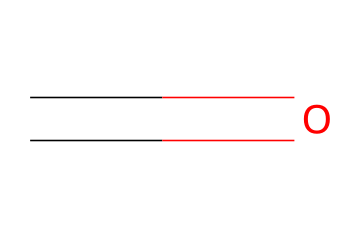What is the structural formula of this compound? The compound's SMILES representation "C=O" indicates that it consists of a carbon atom double-bonded to an oxygen atom. This arrangement defines the aldehyde functional group.
Answer: C=O How many atoms are present in this molecule? By analyzing the SMILES representation "C=O", we can identify two atoms: one carbon atom and one oxygen atom.
Answer: 2 What type of functional group does this compound belong to? The presence of a carbon atom double-bonded to an oxygen atom in the structure indicates that this compound has an aldehyde functional group.
Answer: aldehyde How does formaldehyde contribute to wood preservation? Formaldehyde acts as a preservative by penetrating wood fibers, preventing microbial growth and degradation, thus extending the wood's longevity.
Answer: preserving wood What condition is necessary for the reactivity of formaldehyde with wood? The effective preservation of wood with formaldehyde requires the presence of moisture, which allows formaldehyde to diffuse into wood fibers and react.
Answer: moisture What is the common use of formaldehyde in historical buildings? In historical buildings, formaldehyde is commonly used in the treatment of wood to prevent decay and insect damage, maintaining structural integrity.
Answer: wood treatment 